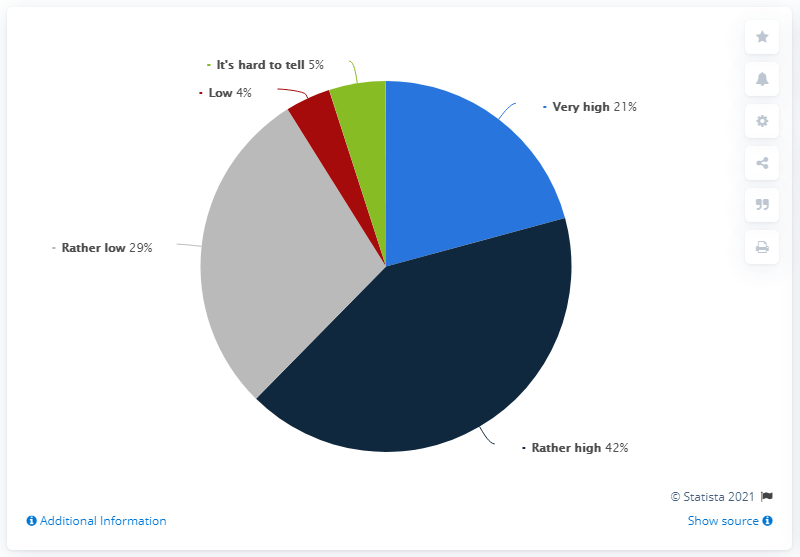Highlight a few significant elements in this photo. There is a difference between very high and rather high. Red indicates a low level. 